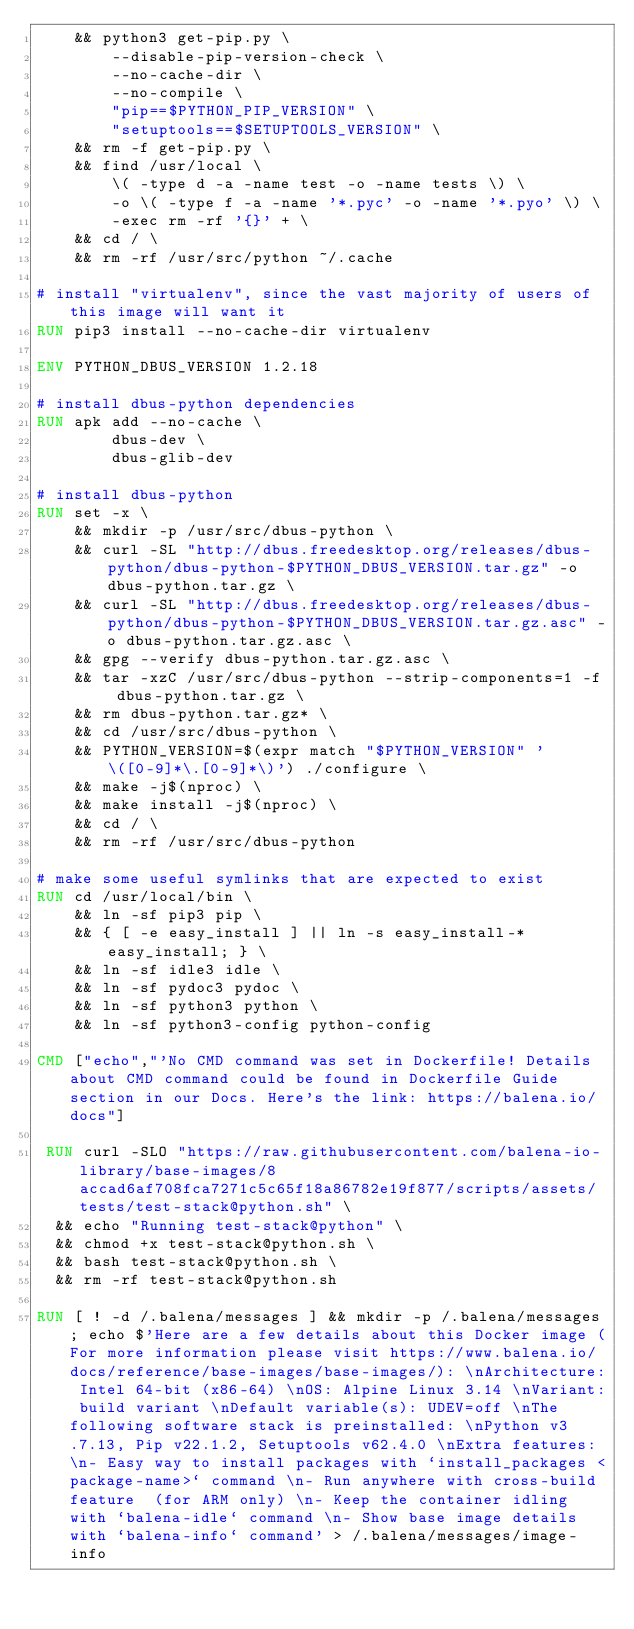<code> <loc_0><loc_0><loc_500><loc_500><_Dockerfile_>    && python3 get-pip.py \
        --disable-pip-version-check \
        --no-cache-dir \
        --no-compile \
        "pip==$PYTHON_PIP_VERSION" \
        "setuptools==$SETUPTOOLS_VERSION" \
	&& rm -f get-pip.py \
	&& find /usr/local \
		\( -type d -a -name test -o -name tests \) \
		-o \( -type f -a -name '*.pyc' -o -name '*.pyo' \) \
		-exec rm -rf '{}' + \
	&& cd / \
	&& rm -rf /usr/src/python ~/.cache

# install "virtualenv", since the vast majority of users of this image will want it
RUN pip3 install --no-cache-dir virtualenv

ENV PYTHON_DBUS_VERSION 1.2.18

# install dbus-python dependencies 
RUN apk add --no-cache \
		dbus-dev \
		dbus-glib-dev

# install dbus-python
RUN set -x \
	&& mkdir -p /usr/src/dbus-python \
	&& curl -SL "http://dbus.freedesktop.org/releases/dbus-python/dbus-python-$PYTHON_DBUS_VERSION.tar.gz" -o dbus-python.tar.gz \
	&& curl -SL "http://dbus.freedesktop.org/releases/dbus-python/dbus-python-$PYTHON_DBUS_VERSION.tar.gz.asc" -o dbus-python.tar.gz.asc \
	&& gpg --verify dbus-python.tar.gz.asc \
	&& tar -xzC /usr/src/dbus-python --strip-components=1 -f dbus-python.tar.gz \
	&& rm dbus-python.tar.gz* \
	&& cd /usr/src/dbus-python \
	&& PYTHON_VERSION=$(expr match "$PYTHON_VERSION" '\([0-9]*\.[0-9]*\)') ./configure \
	&& make -j$(nproc) \
	&& make install -j$(nproc) \
	&& cd / \
	&& rm -rf /usr/src/dbus-python

# make some useful symlinks that are expected to exist
RUN cd /usr/local/bin \
	&& ln -sf pip3 pip \
	&& { [ -e easy_install ] || ln -s easy_install-* easy_install; } \
	&& ln -sf idle3 idle \
	&& ln -sf pydoc3 pydoc \
	&& ln -sf python3 python \
	&& ln -sf python3-config python-config

CMD ["echo","'No CMD command was set in Dockerfile! Details about CMD command could be found in Dockerfile Guide section in our Docs. Here's the link: https://balena.io/docs"]

 RUN curl -SLO "https://raw.githubusercontent.com/balena-io-library/base-images/8accad6af708fca7271c5c65f18a86782e19f877/scripts/assets/tests/test-stack@python.sh" \
  && echo "Running test-stack@python" \
  && chmod +x test-stack@python.sh \
  && bash test-stack@python.sh \
  && rm -rf test-stack@python.sh 

RUN [ ! -d /.balena/messages ] && mkdir -p /.balena/messages; echo $'Here are a few details about this Docker image (For more information please visit https://www.balena.io/docs/reference/base-images/base-images/): \nArchitecture: Intel 64-bit (x86-64) \nOS: Alpine Linux 3.14 \nVariant: build variant \nDefault variable(s): UDEV=off \nThe following software stack is preinstalled: \nPython v3.7.13, Pip v22.1.2, Setuptools v62.4.0 \nExtra features: \n- Easy way to install packages with `install_packages <package-name>` command \n- Run anywhere with cross-build feature  (for ARM only) \n- Keep the container idling with `balena-idle` command \n- Show base image details with `balena-info` command' > /.balena/messages/image-info</code> 